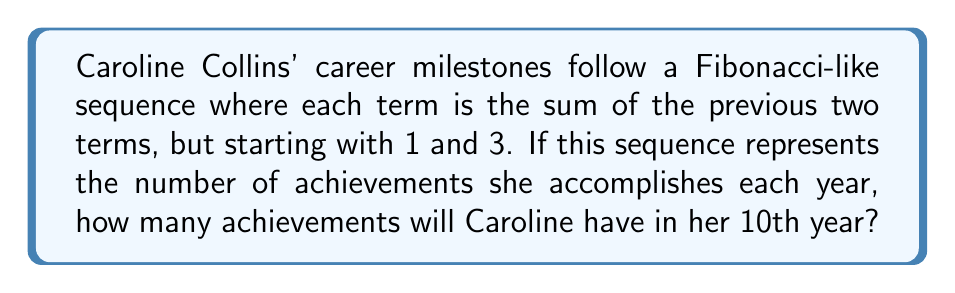Teach me how to tackle this problem. Let's approach this step-by-step:

1) First, let's write out the first few terms of this Fibonacci-like sequence:

   $a_1 = 1$
   $a_2 = 3$
   $a_3 = a_1 + a_2 = 1 + 3 = 4$
   $a_4 = a_2 + a_3 = 3 + 4 = 7$
   $a_5 = a_3 + a_4 = 4 + 7 = 11$

2) We can see the pattern forming. Let's continue:

   $a_6 = a_4 + a_5 = 7 + 11 = 18$
   $a_7 = a_5 + a_6 = 11 + 18 = 29$
   $a_8 = a_6 + a_7 = 18 + 29 = 47$
   $a_9 = a_7 + a_8 = 29 + 47 = 76$

3) Finally, for the 10th term:

   $a_{10} = a_8 + a_9 = 47 + 76 = 123$

Therefore, in her 10th year, Caroline Collins will accomplish 123 achievements according to this sequence.
Answer: 123 